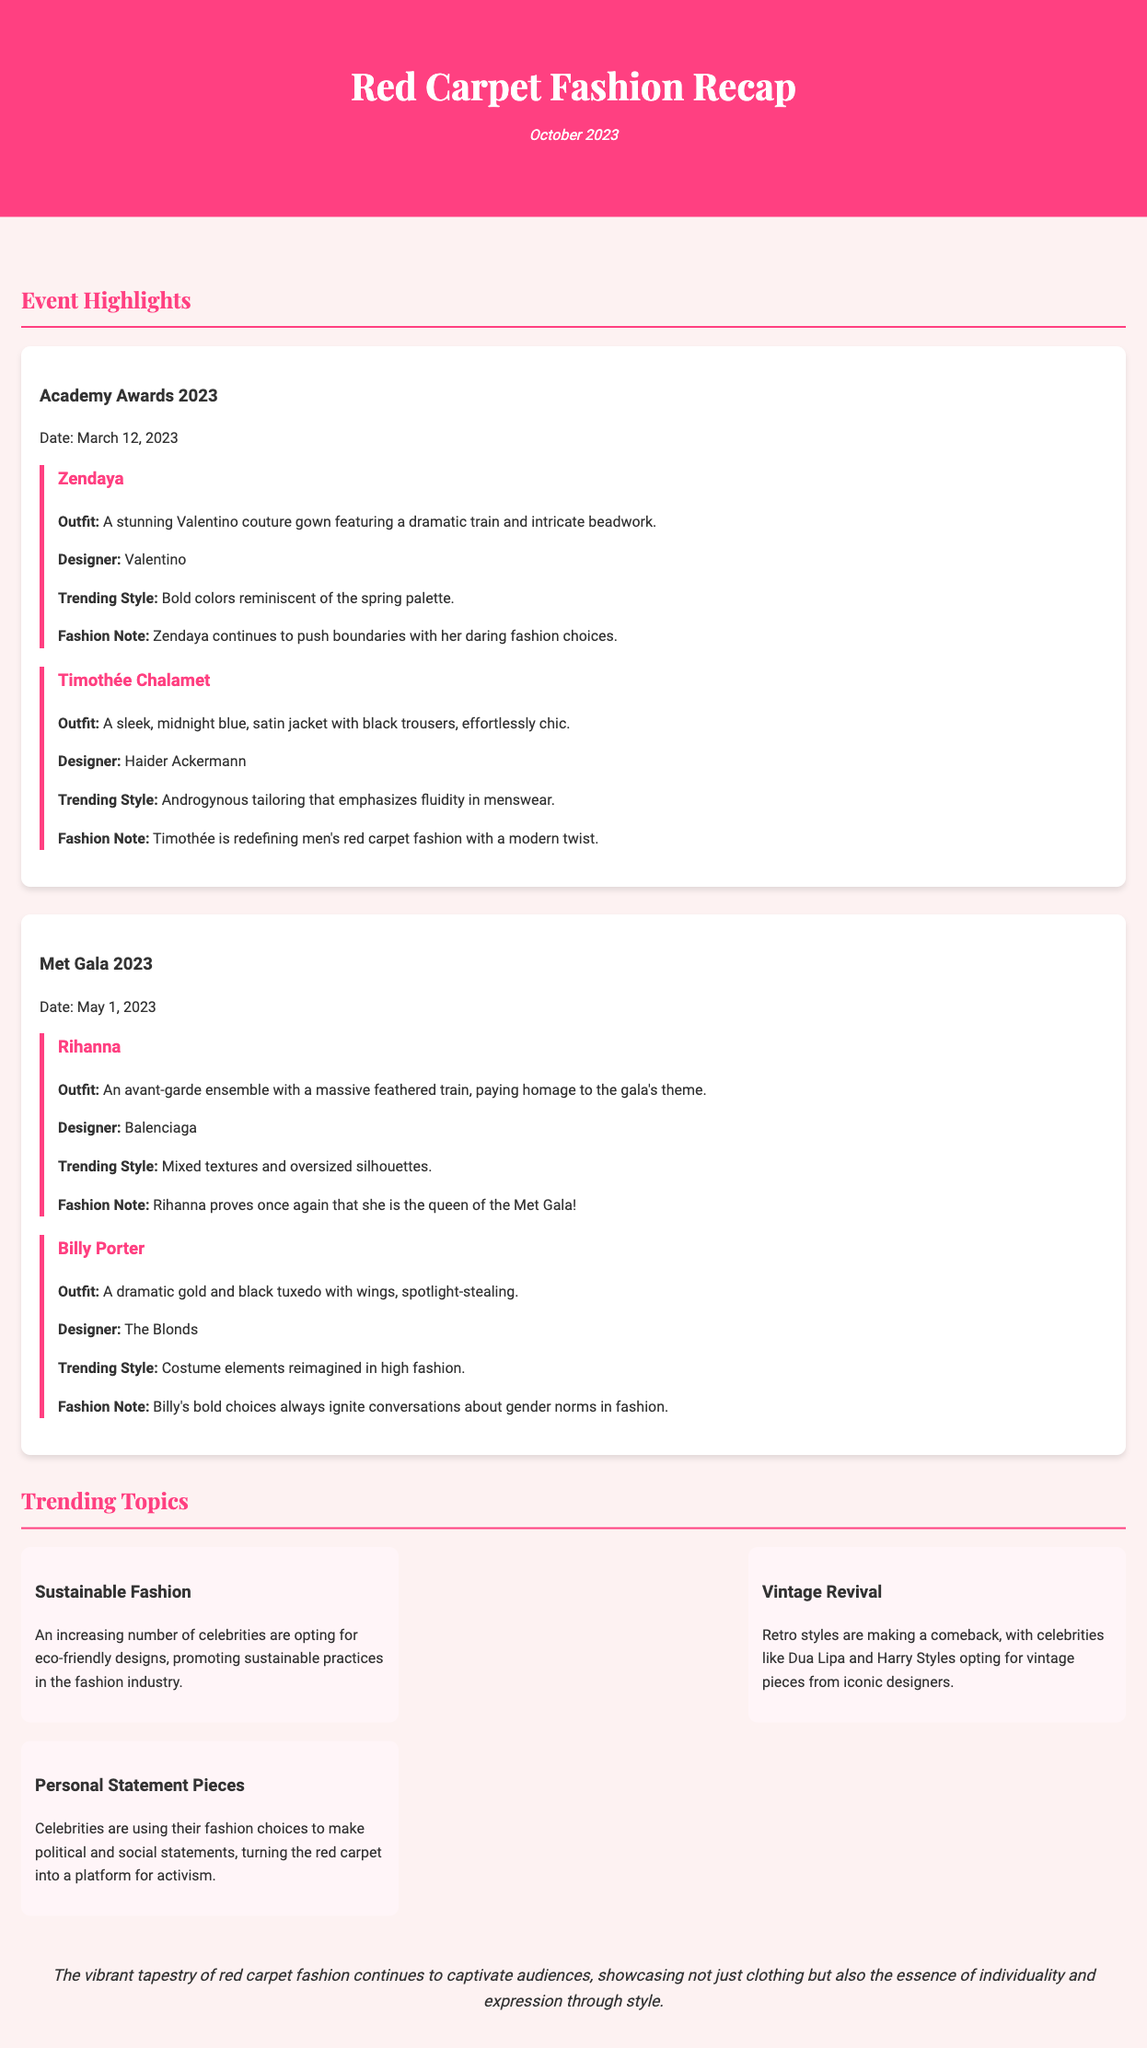What date was the Academy Awards 2023 held? The Academy Awards took place on March 12, 2023.
Answer: March 12, 2023 Who designed Zendaya's gown? Zendaya's stunning gown was designed by Valentino.
Answer: Valentino What type of outfit did Rihanna wear to the Met Gala? Rihanna wore an avant-garde ensemble with a massive feathered train.
Answer: Avant-garde ensemble What is a trending style noted for Timothée Chalamet? His outfit featured androgynous tailoring that emphasizes fluidity in menswear.
Answer: Androgynous tailoring How many trending topics are mentioned in the document? There are three trending topics highlighted in the document.
Answer: Three What fashion choice has been increasingly embraced by celebrities according to the trending topics? Celebrities are opting for eco-friendly designs, promoting sustainable practices.
Answer: Eco-friendly designs Who is noted for proving they are the queen of the Met Gala? Rihanna is noted for proving she is the queen of the Met Gala.
Answer: Rihanna What type of fashion is making a comeback according to the document? Vintage styles are making a comeback among celebrities.
Answer: Vintage styles What is a common thread among the fashion choices made by celebrities at recent events? Celebrities are using their fashion choices to make political and social statements.
Answer: Political and social statements 